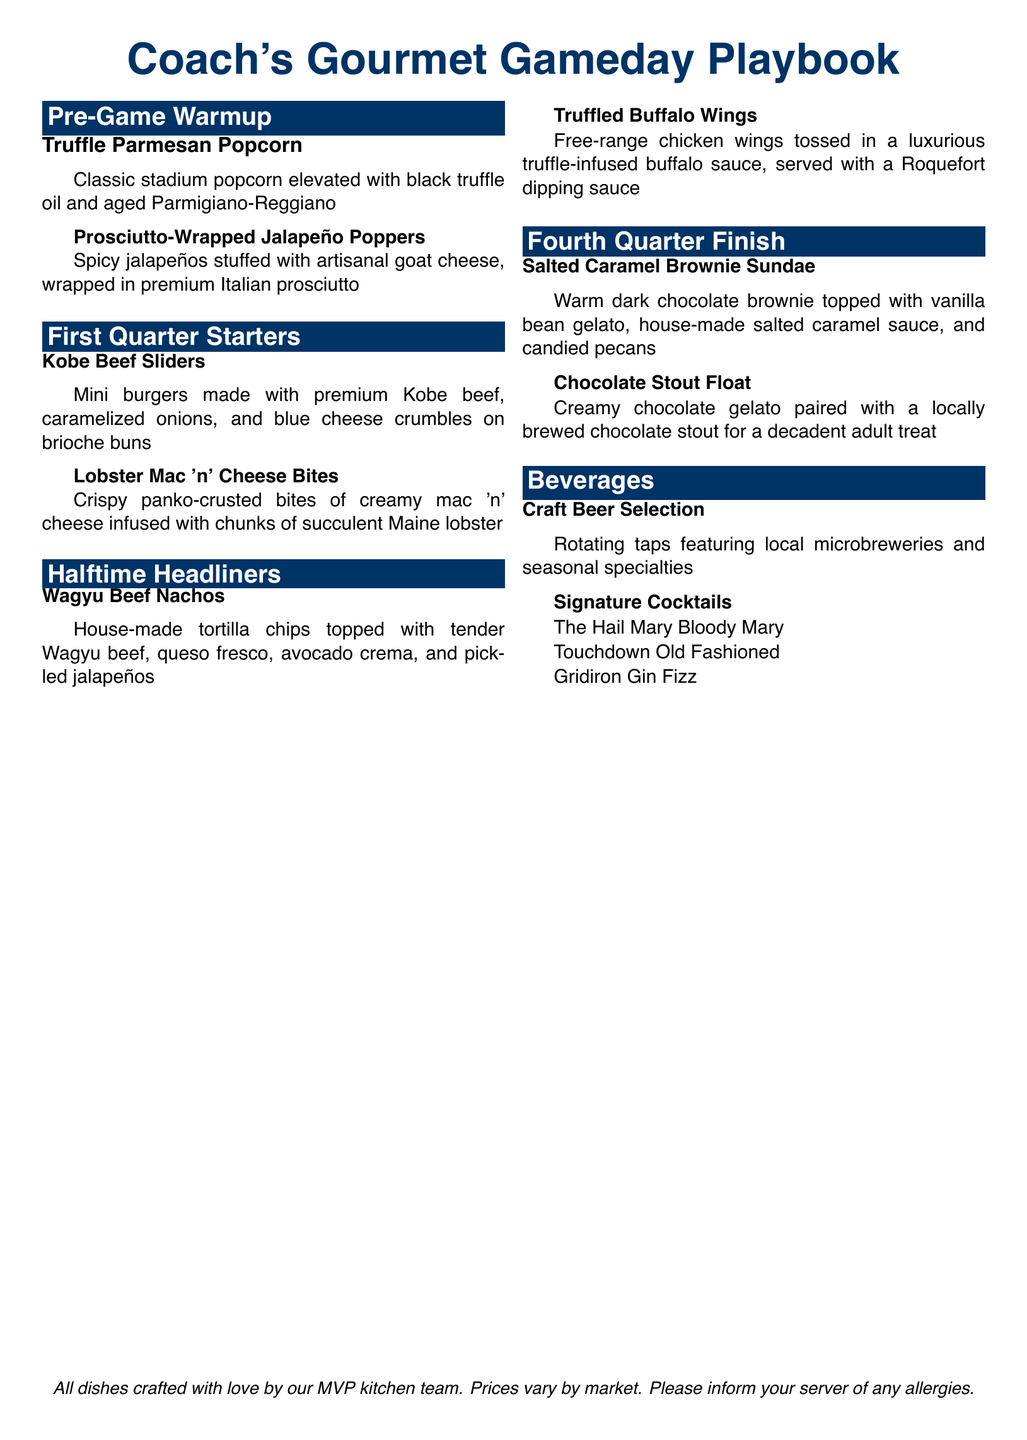What is the title of the menu? The title is prominently displayed at the top of the document as "Coach's Gourmet Gameday Playbook."
Answer: Coach's Gourmet Gameday Playbook What type of dish is Truffle Parmesan Popcorn? The dish is categorized under "Pre-Game Warmup" as a snack.
Answer: Snack Which meat is used in the Kobe Beef Sliders? The dish's main ingredient, as described, is "premium Kobe beef."
Answer: Kobe beef What topping is included in the Wagyu Beef Nachos? The document states that "tender Wagyu beef" is topping for the nachos.
Answer: Wagyu beef What flavor is the Chocolate Stout Float paired with? The Chocolate Stout Float is paired with "locally brewed chocolate stout."
Answer: Chocolate stout Which section contains desserts? The "Fourth Quarter Finish" section includes dessert items.
Answer: Fourth Quarter Finish How many signature cocktails are listed? There are three signature cocktails mentioned in the beverages section.
Answer: Three What is the base flavor of the gelato in the Salted Caramel Brownie Sundae? The document specifies that the gelato is "vanilla bean."
Answer: Vanilla bean What wrapping is used for the Prosciutto-Wrapped Jalapeño Poppers? The poppers are wrapped in "premium Italian prosciutto."
Answer: Italian prosciutto 